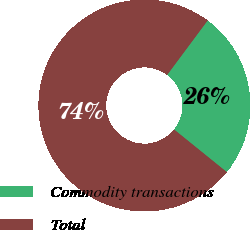Convert chart. <chart><loc_0><loc_0><loc_500><loc_500><pie_chart><fcel>Commodity transactions<fcel>Total<nl><fcel>25.64%<fcel>74.36%<nl></chart> 